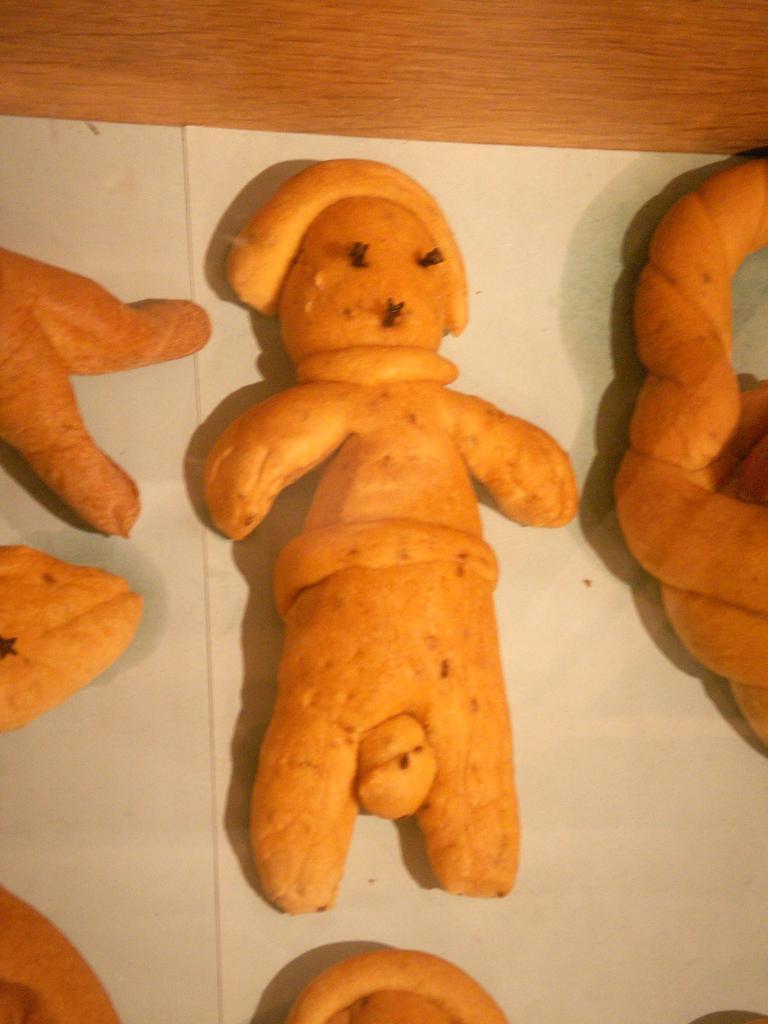Please provide a concise description of this image. In this picture, we see toys which are made up of the carrots. These toys are placed on the white paper and this paper is placed on the wooden table. 